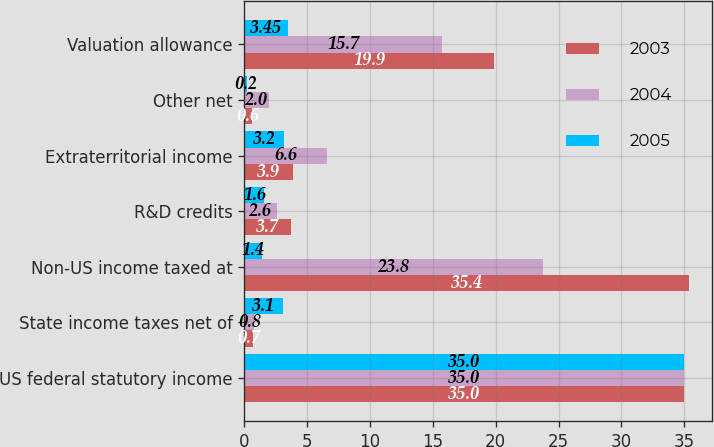<chart> <loc_0><loc_0><loc_500><loc_500><stacked_bar_chart><ecel><fcel>US federal statutory income<fcel>State income taxes net of<fcel>Non-US income taxed at<fcel>R&D credits<fcel>Extraterritorial income<fcel>Other net<fcel>Valuation allowance<nl><fcel>2003<fcel>35<fcel>0.7<fcel>35.4<fcel>3.7<fcel>3.9<fcel>0.6<fcel>19.9<nl><fcel>2004<fcel>35<fcel>0.8<fcel>23.8<fcel>2.6<fcel>6.6<fcel>2<fcel>15.7<nl><fcel>2005<fcel>35<fcel>3.1<fcel>1.4<fcel>1.6<fcel>3.2<fcel>0.2<fcel>3.45<nl></chart> 